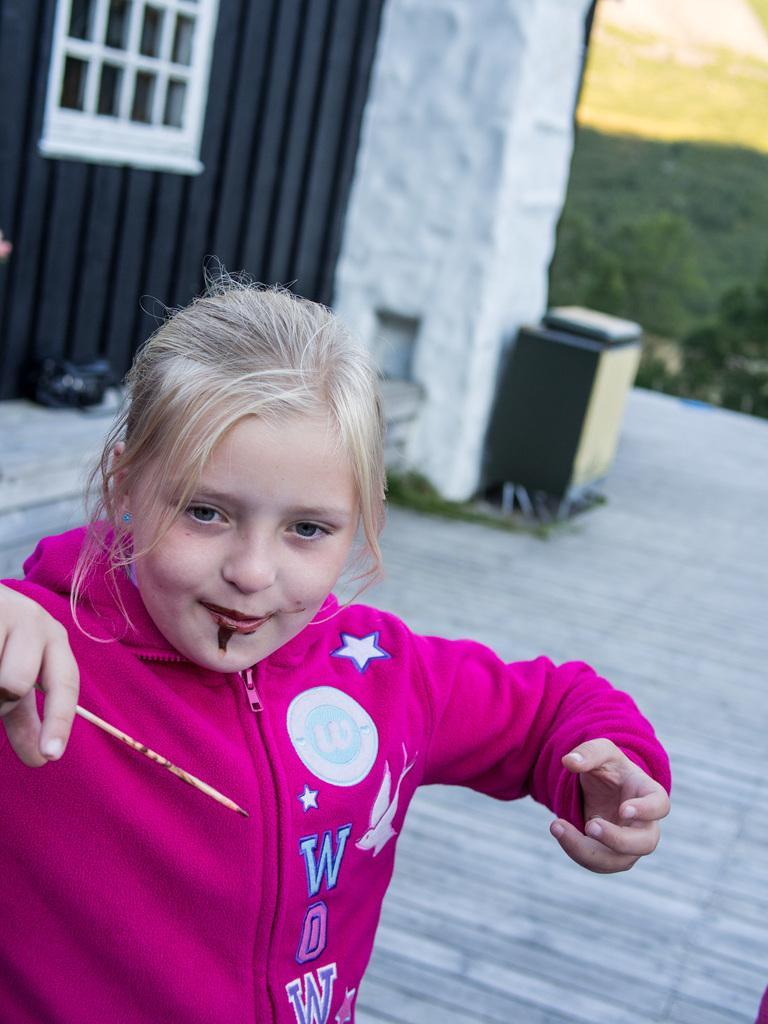Provide a one-sentence caption for the provided image. A young blonde girl is wearing a hot pink hoodie that says WOW. 